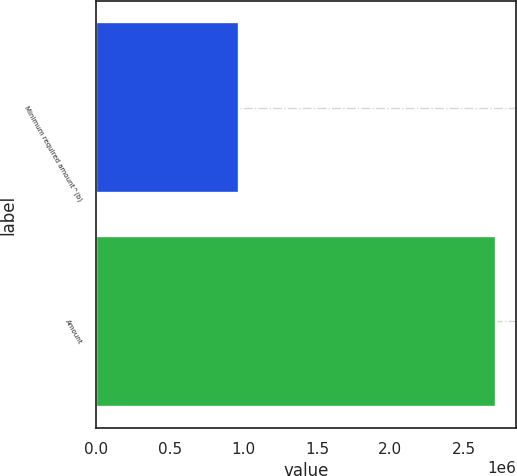<chart> <loc_0><loc_0><loc_500><loc_500><bar_chart><fcel>Minimum required amount^(b)<fcel>Amount<nl><fcel>972521<fcel>2.72014e+06<nl></chart> 